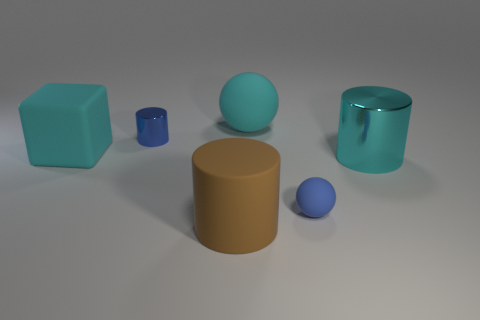Add 2 tiny blue matte things. How many objects exist? 8 Subtract all spheres. How many objects are left? 4 Add 1 large brown matte cylinders. How many large brown matte cylinders are left? 2 Add 5 cyan rubber cubes. How many cyan rubber cubes exist? 6 Subtract 0 red blocks. How many objects are left? 6 Subtract all cyan rubber spheres. Subtract all tiny balls. How many objects are left? 4 